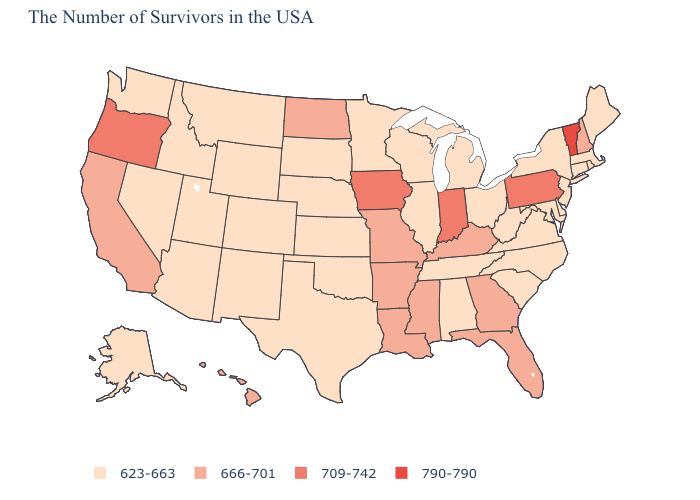What is the lowest value in states that border Texas?
Give a very brief answer. 623-663. What is the highest value in the MidWest ?
Be succinct. 709-742. What is the lowest value in states that border Maryland?
Quick response, please. 623-663. Which states hav the highest value in the West?
Quick response, please. Oregon. What is the value of Nevada?
Quick response, please. 623-663. What is the highest value in the Northeast ?
Keep it brief. 790-790. What is the lowest value in states that border Maryland?
Be succinct. 623-663. What is the value of Delaware?
Quick response, please. 623-663. Does Vermont have the highest value in the USA?
Concise answer only. Yes. What is the lowest value in the Northeast?
Write a very short answer. 623-663. What is the lowest value in the USA?
Keep it brief. 623-663. What is the lowest value in the USA?
Concise answer only. 623-663. Name the states that have a value in the range 623-663?
Quick response, please. Maine, Massachusetts, Rhode Island, Connecticut, New York, New Jersey, Delaware, Maryland, Virginia, North Carolina, South Carolina, West Virginia, Ohio, Michigan, Alabama, Tennessee, Wisconsin, Illinois, Minnesota, Kansas, Nebraska, Oklahoma, Texas, South Dakota, Wyoming, Colorado, New Mexico, Utah, Montana, Arizona, Idaho, Nevada, Washington, Alaska. Does Vermont have the highest value in the USA?
Concise answer only. Yes. 